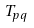<formula> <loc_0><loc_0><loc_500><loc_500>T _ { p q }</formula> 